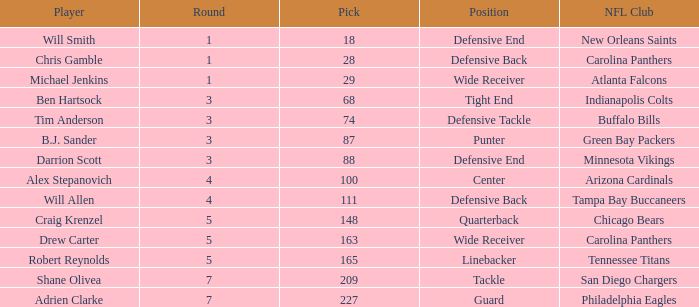What is the highest round number of a Pick after 209. 7.0. 